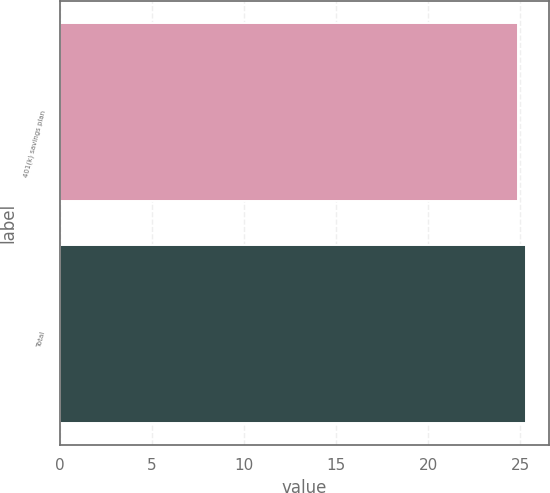Convert chart. <chart><loc_0><loc_0><loc_500><loc_500><bar_chart><fcel>401(k) savings plan<fcel>Total<nl><fcel>24.9<fcel>25.3<nl></chart> 